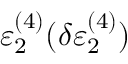Convert formula to latex. <formula><loc_0><loc_0><loc_500><loc_500>\varepsilon _ { 2 } ^ { ( 4 ) } ( \delta \varepsilon _ { 2 } ^ { ( 4 ) } )</formula> 